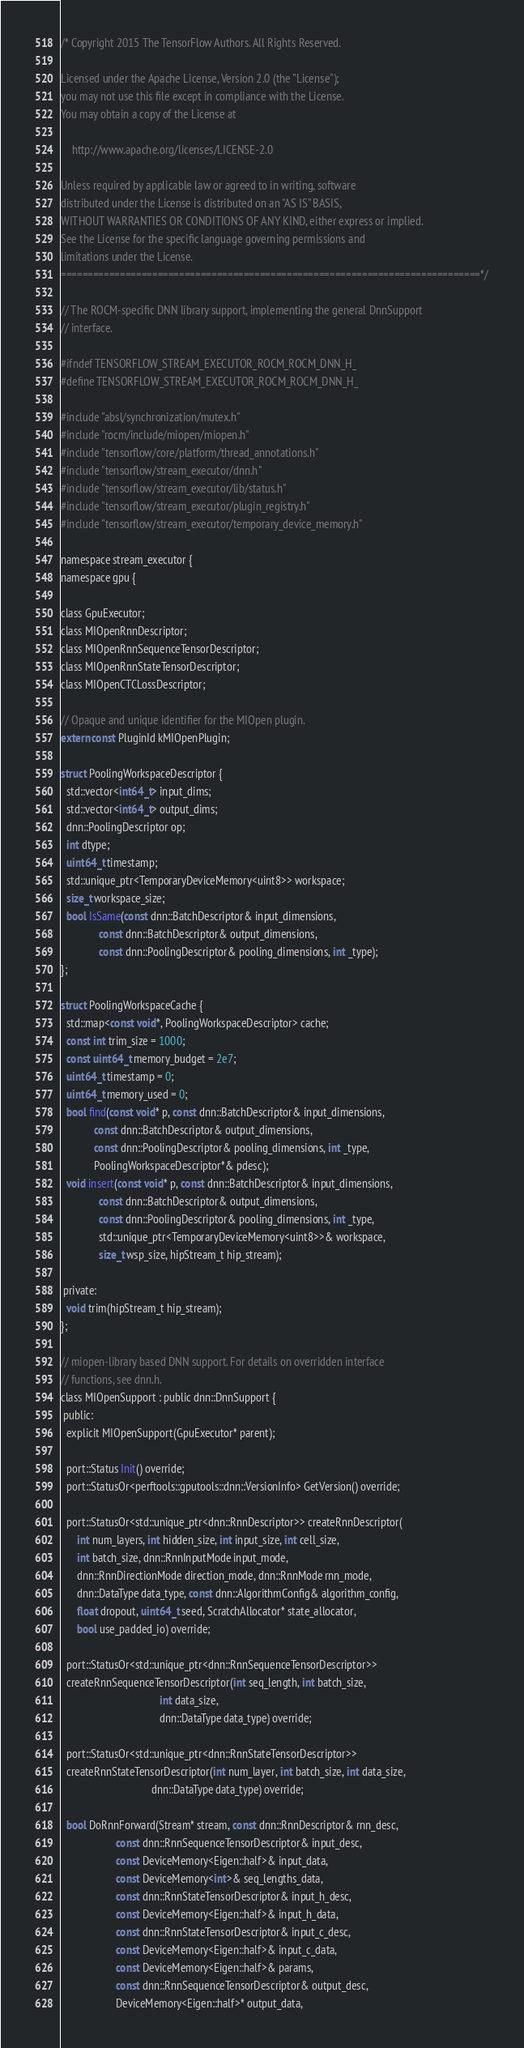Convert code to text. <code><loc_0><loc_0><loc_500><loc_500><_C_>/* Copyright 2015 The TensorFlow Authors. All Rights Reserved.

Licensed under the Apache License, Version 2.0 (the "License");
you may not use this file except in compliance with the License.
You may obtain a copy of the License at

    http://www.apache.org/licenses/LICENSE-2.0

Unless required by applicable law or agreed to in writing, software
distributed under the License is distributed on an "AS IS" BASIS,
WITHOUT WARRANTIES OR CONDITIONS OF ANY KIND, either express or implied.
See the License for the specific language governing permissions and
limitations under the License.
==============================================================================*/

// The ROCM-specific DNN library support, implementing the general DnnSupport
// interface.

#ifndef TENSORFLOW_STREAM_EXECUTOR_ROCM_ROCM_DNN_H_
#define TENSORFLOW_STREAM_EXECUTOR_ROCM_ROCM_DNN_H_

#include "absl/synchronization/mutex.h"
#include "rocm/include/miopen/miopen.h"
#include "tensorflow/core/platform/thread_annotations.h"
#include "tensorflow/stream_executor/dnn.h"
#include "tensorflow/stream_executor/lib/status.h"
#include "tensorflow/stream_executor/plugin_registry.h"
#include "tensorflow/stream_executor/temporary_device_memory.h"

namespace stream_executor {
namespace gpu {

class GpuExecutor;
class MIOpenRnnDescriptor;
class MIOpenRnnSequenceTensorDescriptor;
class MIOpenRnnStateTensorDescriptor;
class MIOpenCTCLossDescriptor;

// Opaque and unique identifier for the MIOpen plugin.
extern const PluginId kMIOpenPlugin;

struct PoolingWorkspaceDescriptor {
  std::vector<int64_t> input_dims;
  std::vector<int64_t> output_dims;
  dnn::PoolingDescriptor op;
  int dtype;
  uint64_t timestamp;
  std::unique_ptr<TemporaryDeviceMemory<uint8>> workspace;
  size_t workspace_size;
  bool IsSame(const dnn::BatchDescriptor& input_dimensions,
              const dnn::BatchDescriptor& output_dimensions,
              const dnn::PoolingDescriptor& pooling_dimensions, int _type);
};

struct PoolingWorkspaceCache {
  std::map<const void*, PoolingWorkspaceDescriptor> cache;
  const int trim_size = 1000;
  const uint64_t memory_budget = 2e7;
  uint64_t timestamp = 0;
  uint64_t memory_used = 0;
  bool find(const void* p, const dnn::BatchDescriptor& input_dimensions,
            const dnn::BatchDescriptor& output_dimensions,
            const dnn::PoolingDescriptor& pooling_dimensions, int _type,
            PoolingWorkspaceDescriptor*& pdesc);
  void insert(const void* p, const dnn::BatchDescriptor& input_dimensions,
              const dnn::BatchDescriptor& output_dimensions,
              const dnn::PoolingDescriptor& pooling_dimensions, int _type,
              std::unique_ptr<TemporaryDeviceMemory<uint8>>& workspace,
              size_t wsp_size, hipStream_t hip_stream);

 private:
  void trim(hipStream_t hip_stream);
};

// miopen-library based DNN support. For details on overridden interface
// functions, see dnn.h.
class MIOpenSupport : public dnn::DnnSupport {
 public:
  explicit MIOpenSupport(GpuExecutor* parent);

  port::Status Init() override;
  port::StatusOr<perftools::gputools::dnn::VersionInfo> GetVersion() override;

  port::StatusOr<std::unique_ptr<dnn::RnnDescriptor>> createRnnDescriptor(
      int num_layers, int hidden_size, int input_size, int cell_size,
      int batch_size, dnn::RnnInputMode input_mode,
      dnn::RnnDirectionMode direction_mode, dnn::RnnMode rnn_mode,
      dnn::DataType data_type, const dnn::AlgorithmConfig& algorithm_config,
      float dropout, uint64_t seed, ScratchAllocator* state_allocator,
      bool use_padded_io) override;

  port::StatusOr<std::unique_ptr<dnn::RnnSequenceTensorDescriptor>>
  createRnnSequenceTensorDescriptor(int seq_length, int batch_size,
                                    int data_size,
                                    dnn::DataType data_type) override;

  port::StatusOr<std::unique_ptr<dnn::RnnStateTensorDescriptor>>
  createRnnStateTensorDescriptor(int num_layer, int batch_size, int data_size,
                                 dnn::DataType data_type) override;

  bool DoRnnForward(Stream* stream, const dnn::RnnDescriptor& rnn_desc,
                    const dnn::RnnSequenceTensorDescriptor& input_desc,
                    const DeviceMemory<Eigen::half>& input_data,
                    const DeviceMemory<int>& seq_lengths_data,
                    const dnn::RnnStateTensorDescriptor& input_h_desc,
                    const DeviceMemory<Eigen::half>& input_h_data,
                    const dnn::RnnStateTensorDescriptor& input_c_desc,
                    const DeviceMemory<Eigen::half>& input_c_data,
                    const DeviceMemory<Eigen::half>& params,
                    const dnn::RnnSequenceTensorDescriptor& output_desc,
                    DeviceMemory<Eigen::half>* output_data,</code> 